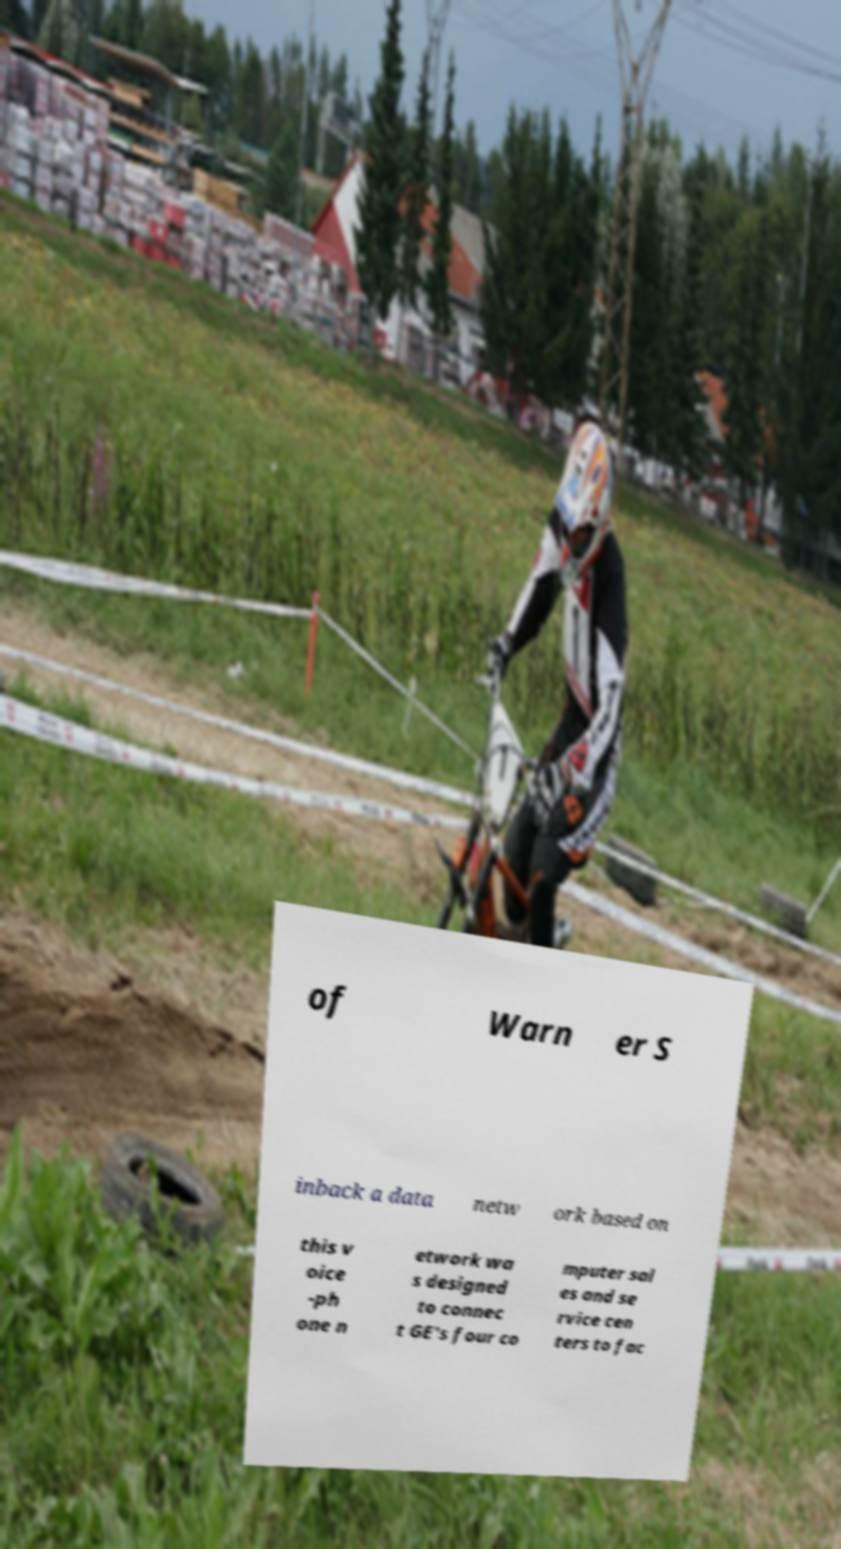There's text embedded in this image that I need extracted. Can you transcribe it verbatim? of Warn er S inback a data netw ork based on this v oice -ph one n etwork wa s designed to connec t GE's four co mputer sal es and se rvice cen ters to fac 